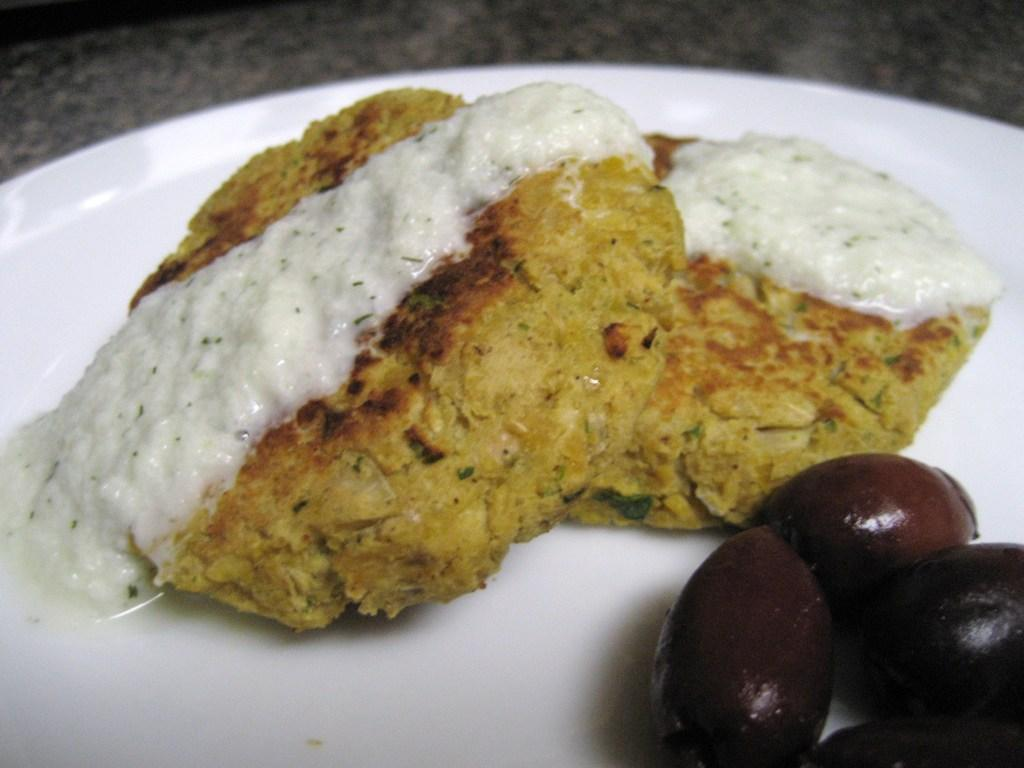What object is present on the plate in the image? There is a food item on the plate in the image. Can you describe the background of the image? The background of the image is blurred. What word is written on the spoon in the image? There is no spoon present in the image, so it is not possible to determine if any words are written on it. 